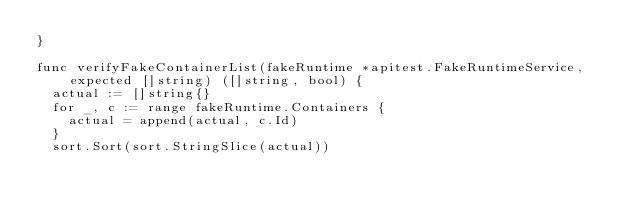<code> <loc_0><loc_0><loc_500><loc_500><_Go_>}

func verifyFakeContainerList(fakeRuntime *apitest.FakeRuntimeService, expected []string) ([]string, bool) {
	actual := []string{}
	for _, c := range fakeRuntime.Containers {
		actual = append(actual, c.Id)
	}
	sort.Sort(sort.StringSlice(actual))</code> 